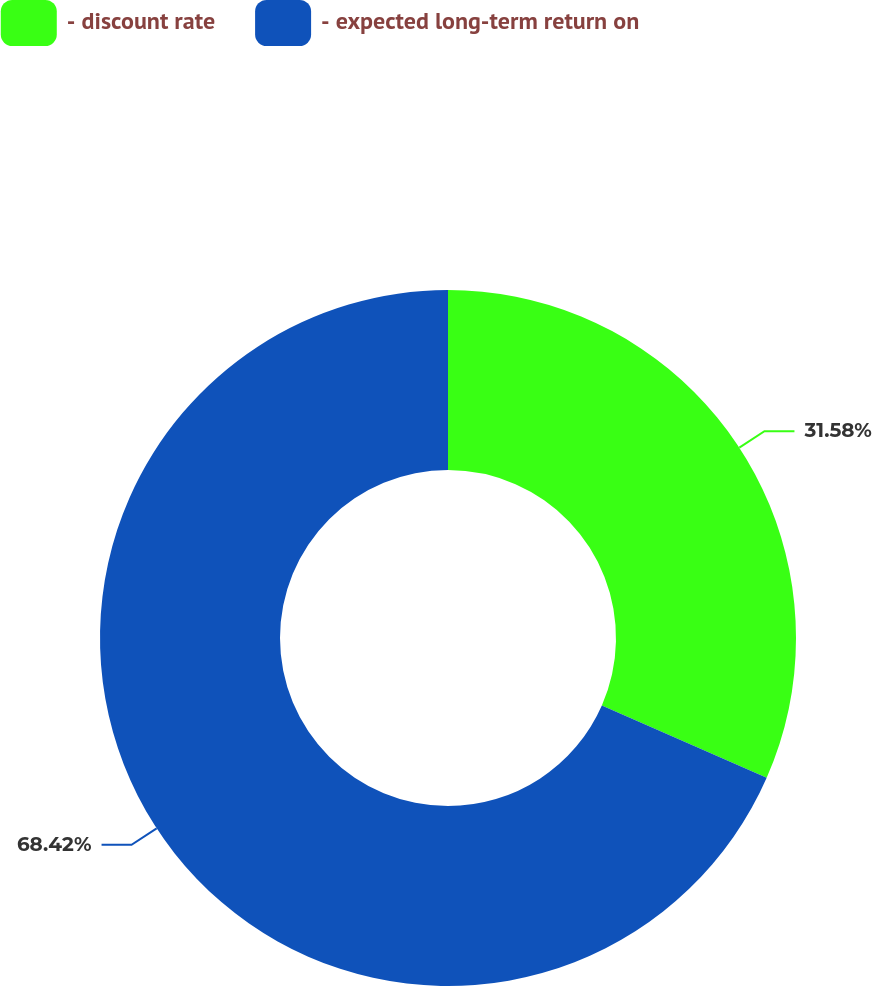<chart> <loc_0><loc_0><loc_500><loc_500><pie_chart><fcel>- discount rate<fcel>- expected long-term return on<nl><fcel>31.58%<fcel>68.42%<nl></chart> 